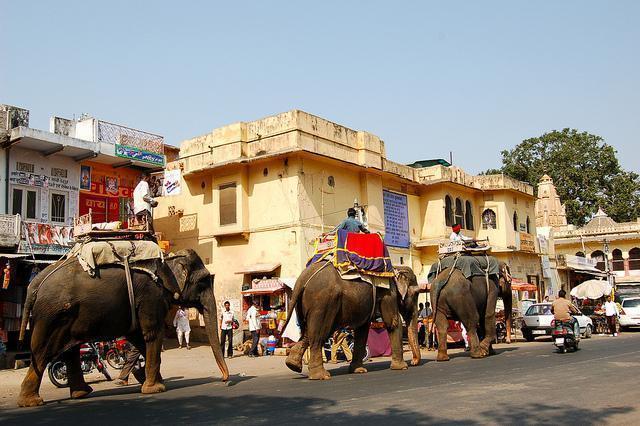Which mode of transport in use here uses less gasoline?
Select the accurate response from the four choices given to answer the question.
Options: Elephants, motorcycle, van, bus. Elephants. 